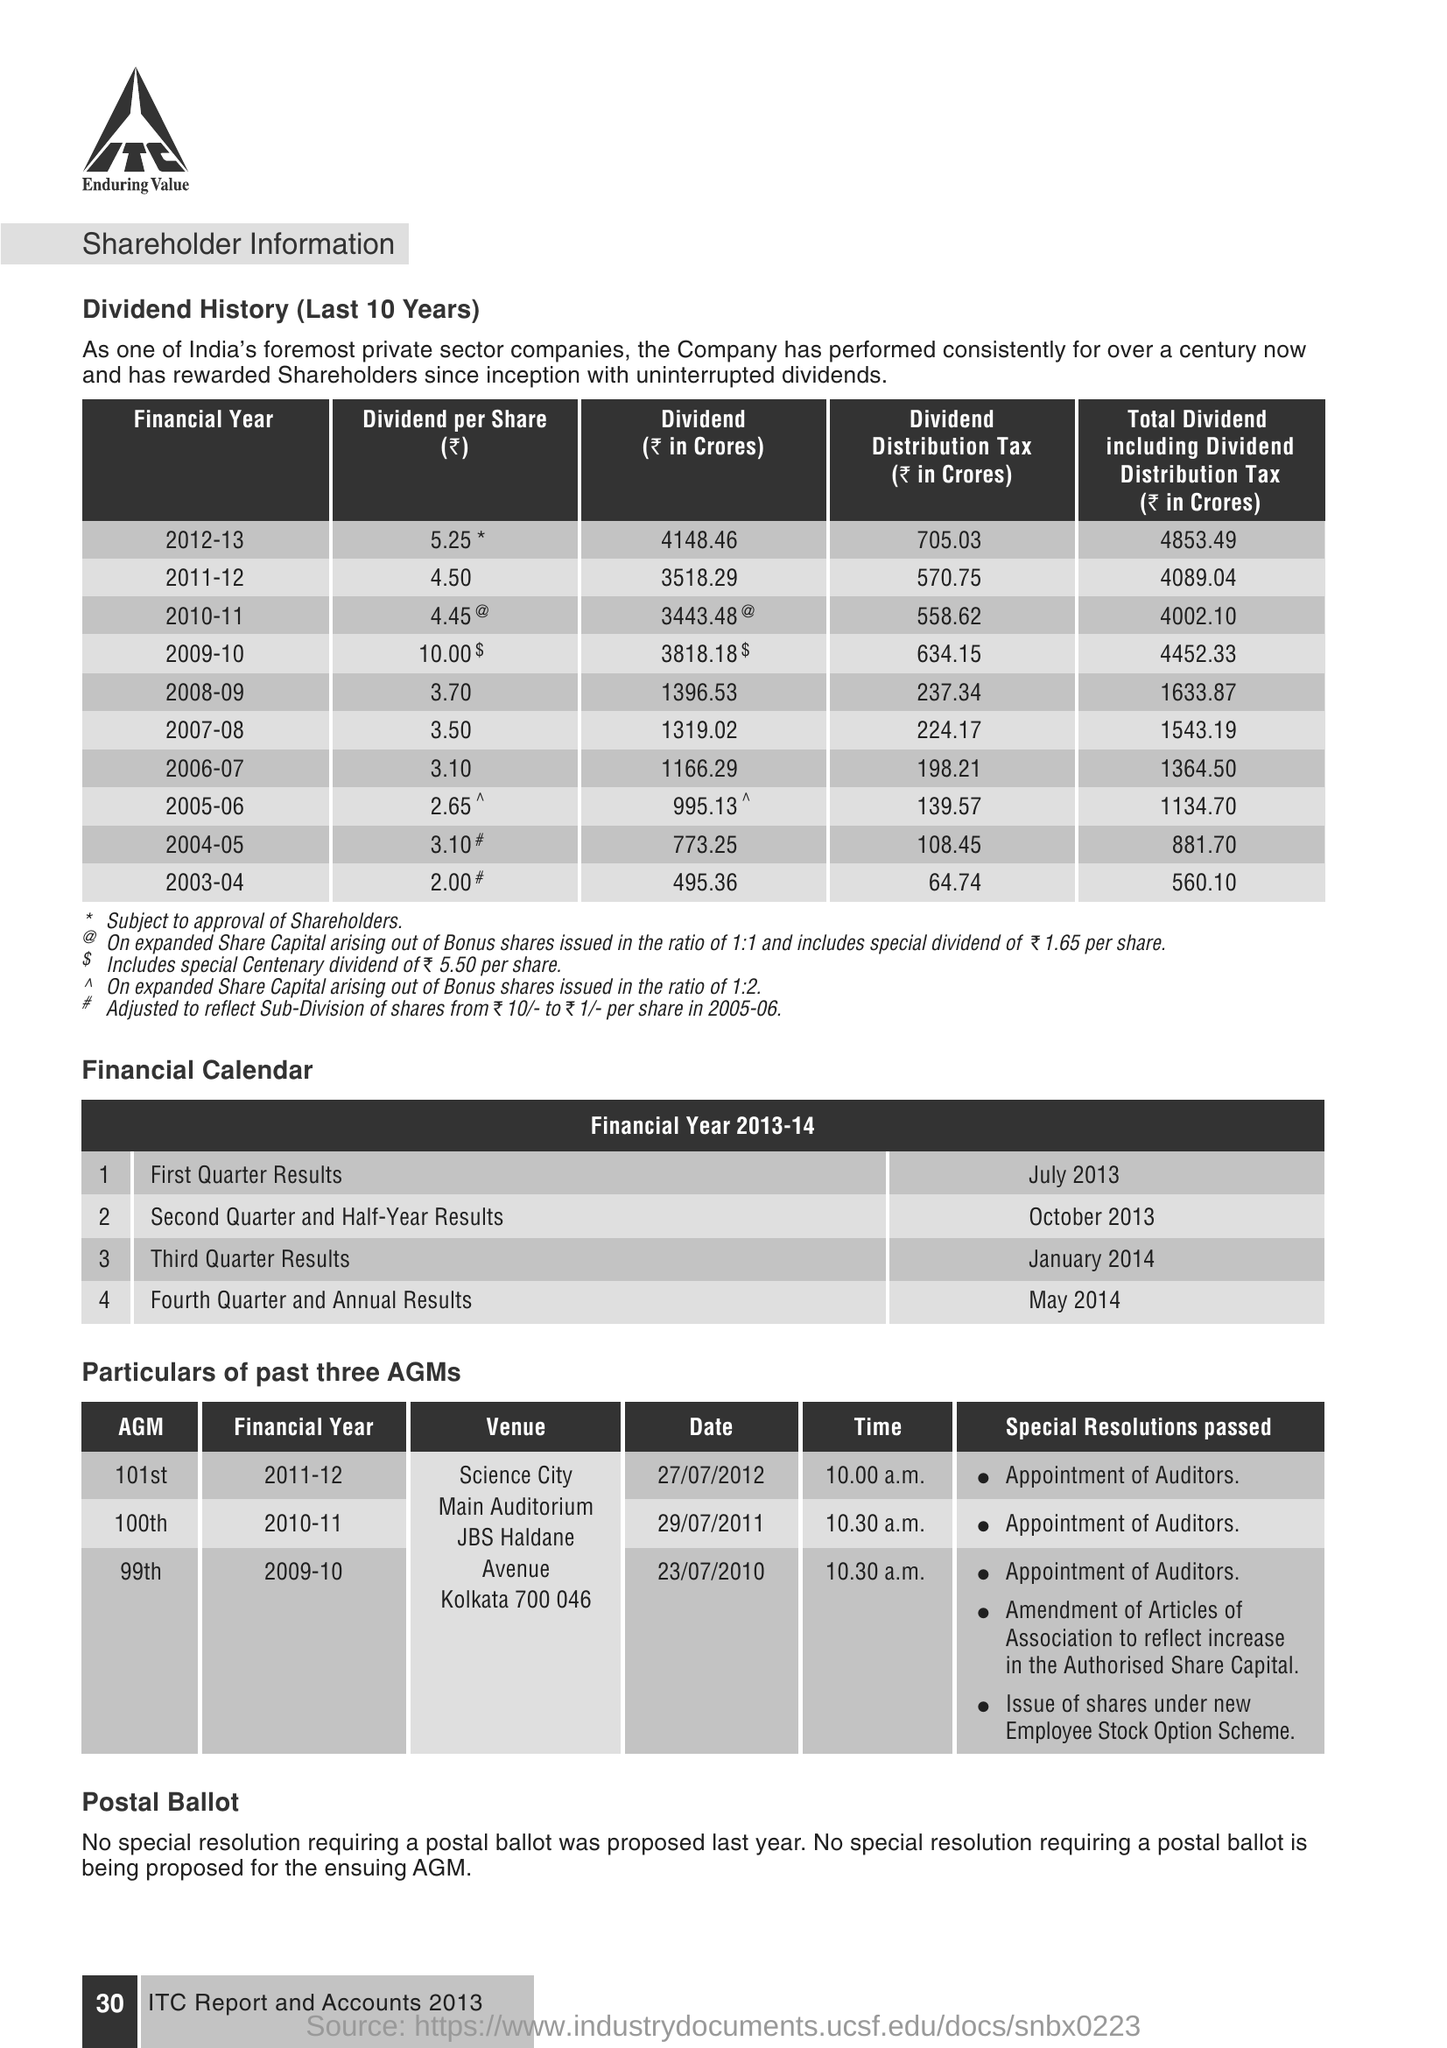Can you provide the dividend per share announced in the financial year 2011-12? In the financial year 2011-12, the dividend per share announced was 4.50 INR. 